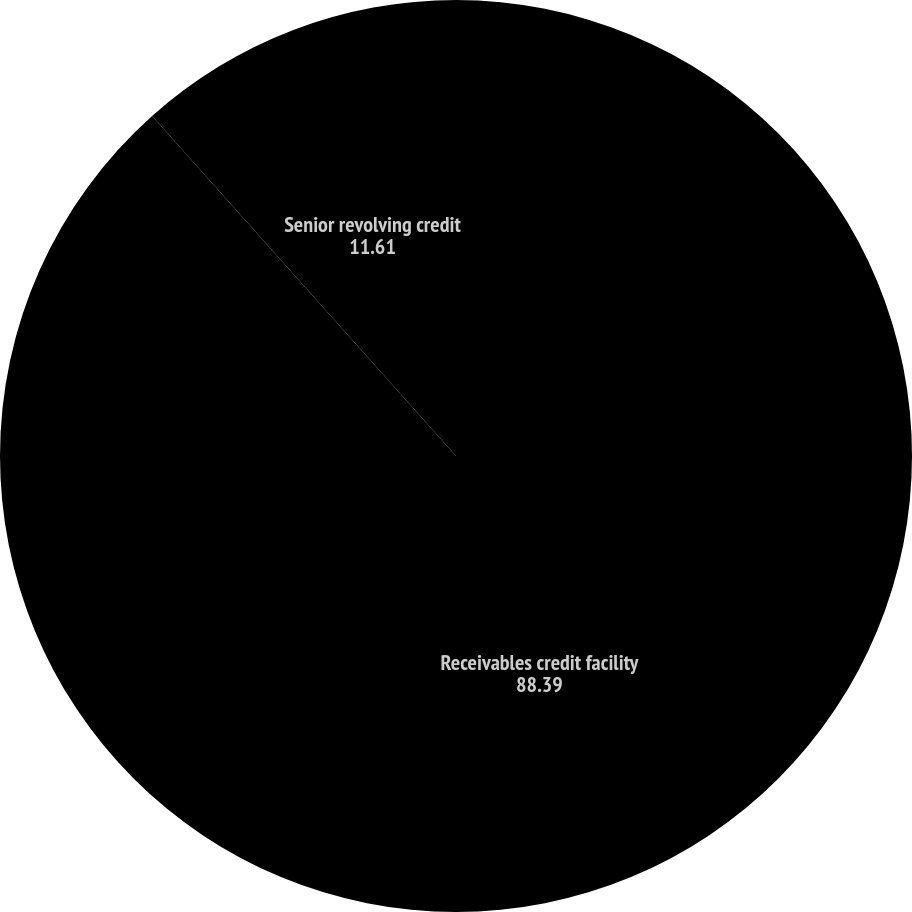Convert chart. <chart><loc_0><loc_0><loc_500><loc_500><pie_chart><fcel>Receivables credit facility<fcel>Senior revolving credit<nl><fcel>88.39%<fcel>11.61%<nl></chart> 